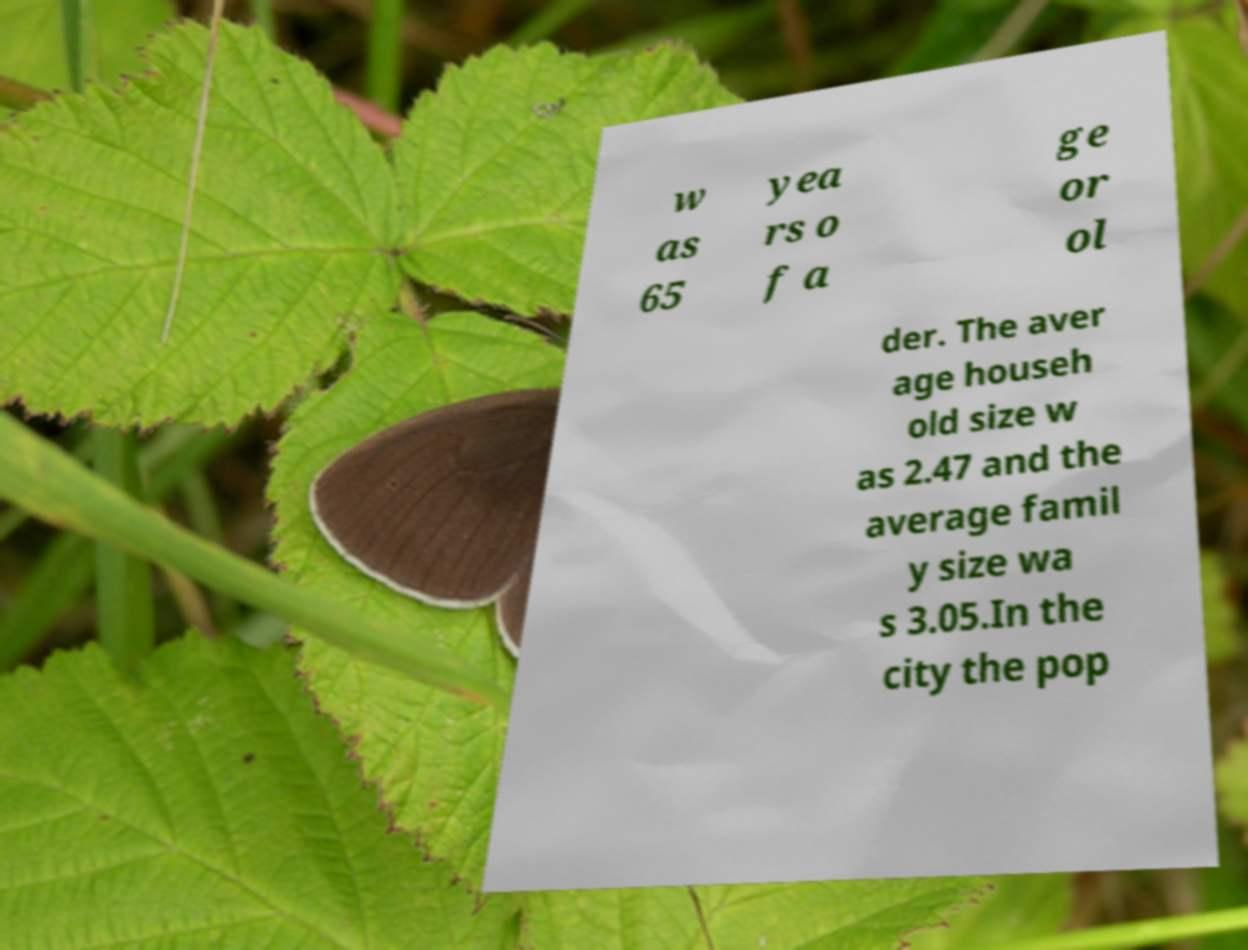Please identify and transcribe the text found in this image. w as 65 yea rs o f a ge or ol der. The aver age househ old size w as 2.47 and the average famil y size wa s 3.05.In the city the pop 